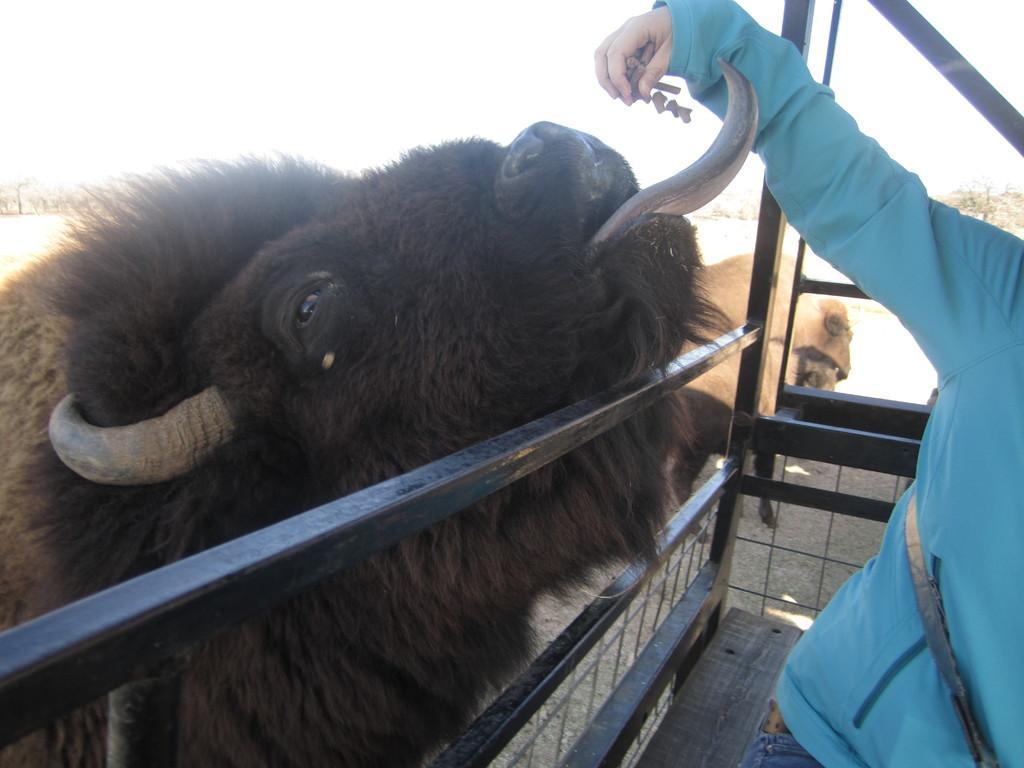In one or two sentences, can you explain what this image depicts? In this picture we can see a person giving food to an animal. There is a cage. We can see few trees in the background. 